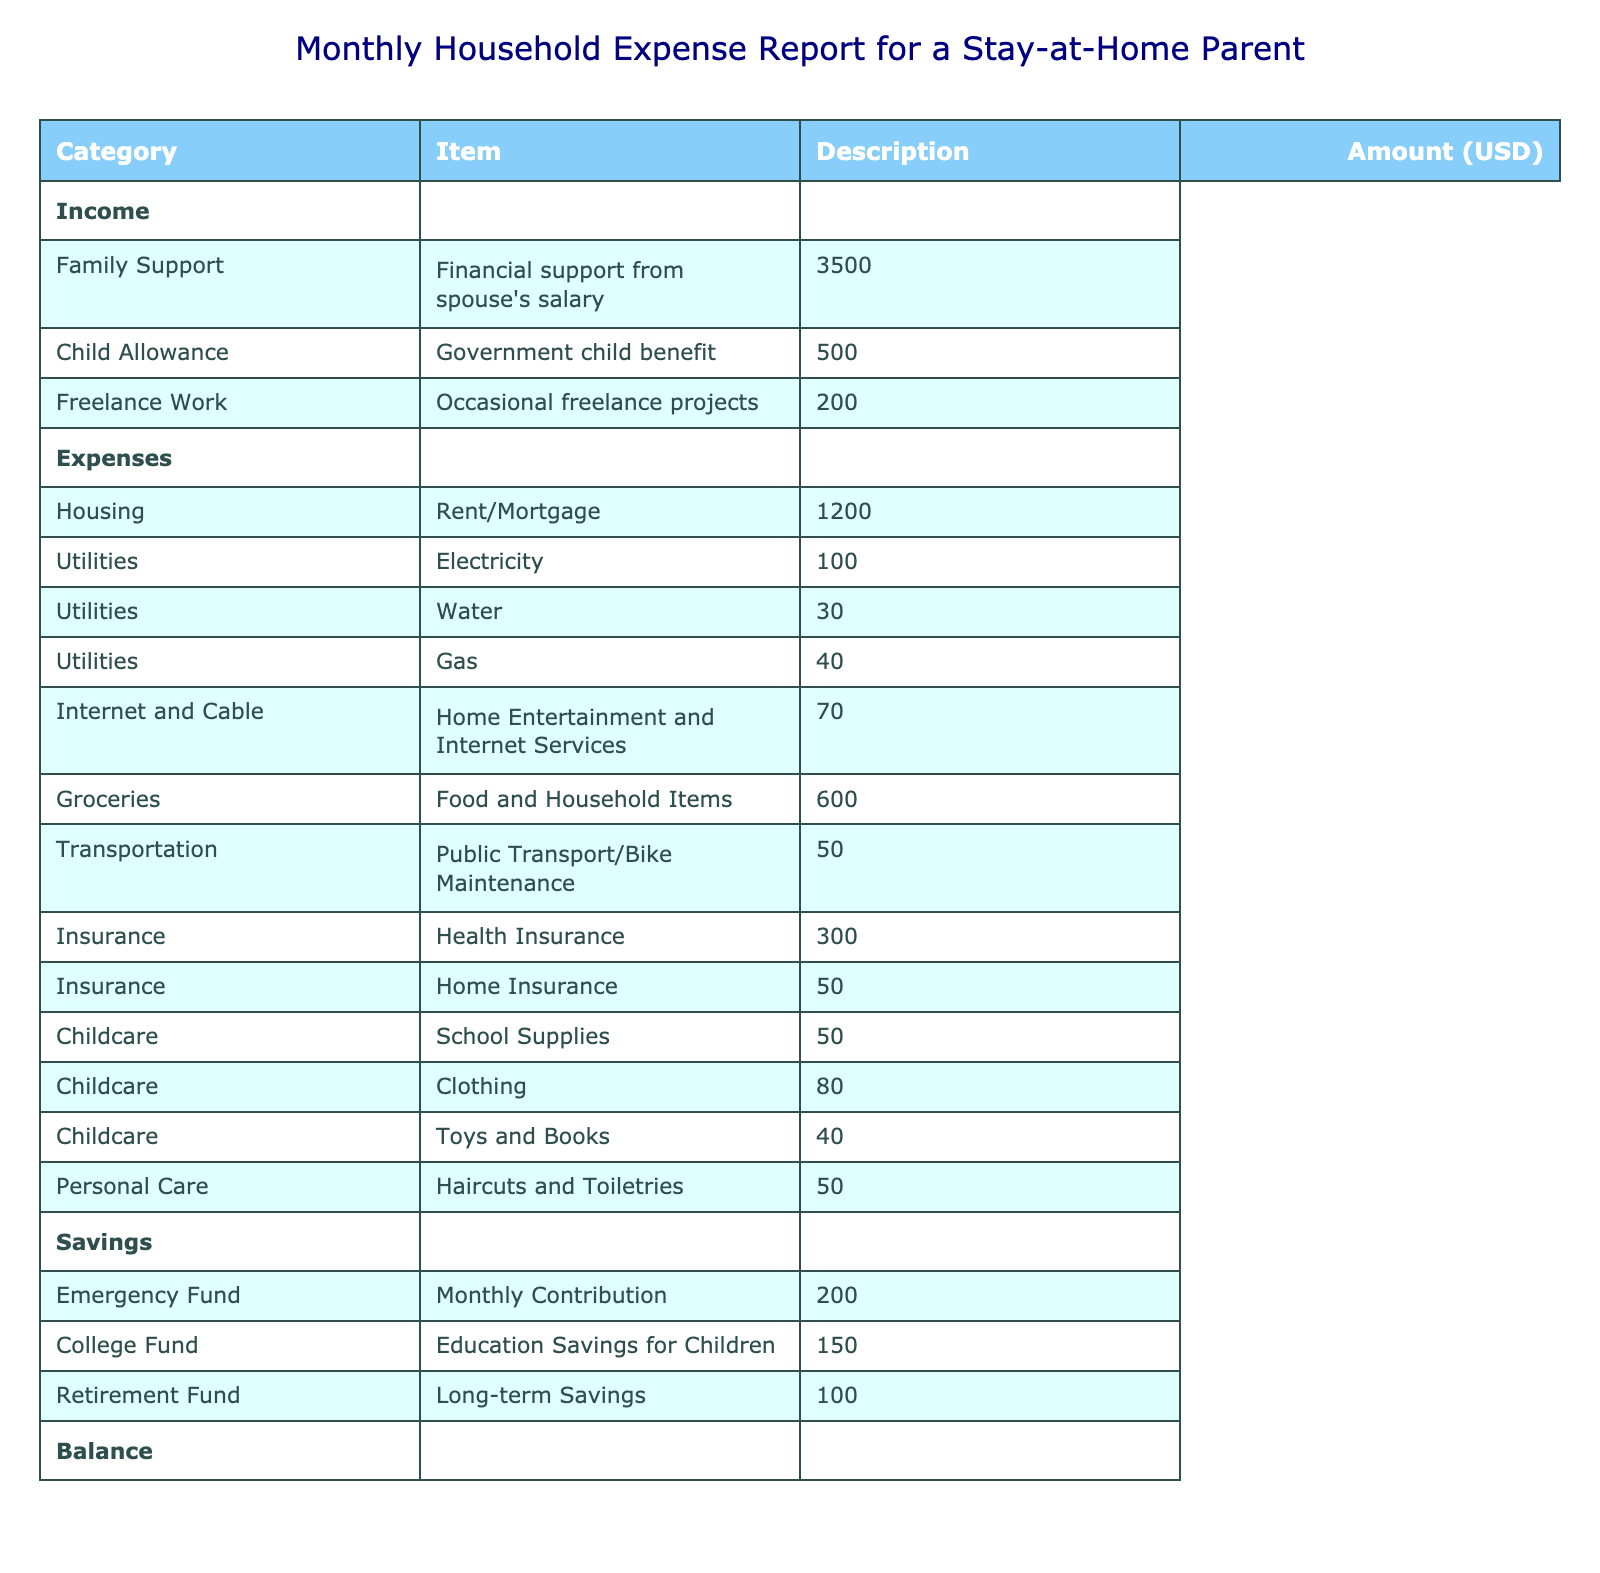What is the total income reported in the table? The total income is calculated by adding the amounts from all income sources. The income sources are Family Support ($3500), Child Allowance ($500), and Freelance Work ($200). Adding these up gives us $3500 + $500 + $200 = $4200.
Answer: 4200 What is the total amount spent on childcare? The total amount spent on childcare includes School Supplies ($50), Clothing ($80), and Toys and Books ($40). Adding these amounts together results in $50 + $80 + $40 = $170.
Answer: 170 Is the total savings higher than total expenses? To answer this, we compare total savings ($450) to total expenses ($1990). Since $450 is less than $1990, the statement is false.
Answer: No How much is spent on utilities each month? The total spent on utilities includes Electricity ($100), Water ($30), and Gas ($40). Adding these amounts provides the total: $100 + $30 + $40 = $170.
Answer: 170 What is the monthly contribution to the emergency fund? The table specifies the emergency fund contribution as $200. Therefore, the amount contributed monthly is directly stated.
Answer: 200 What is the difference between total income and total expenses? First, the total income is $4200 and the total expenses are $1990. To find the difference, we subtract the total expenses from total income: $4200 - $1990 = $2210.
Answer: 2210 Do the monthly expenses for housing exceed the expenses for personal care? The monthly expense for housing is $1200, while the personal care expense is $50. Since $1200 is greater than $50, the answer is yes.
Answer: Yes How much is allocated to the college fund compared to the retirement fund? The college fund allocation is $150 and the retirement fund allocation is $100. To compare, $150 for the college fund is greater than $100 for the retirement fund. This shows that more is allocated towards the college fund.
Answer: College fund is greater What is the total amount spent on groceries and utilities combined? The total spent on groceries is $600 and on utilities is $170. To find the total for both, we sum these amounts: $600 + $170 = $770.
Answer: 770 What percentage of total income is saved? The total savings amount is $450. To find the percentage saved from total income, we use the formula: (savings/income) * 100 = ($450/$4200) * 100 = 10.71%.
Answer: 10.71% 